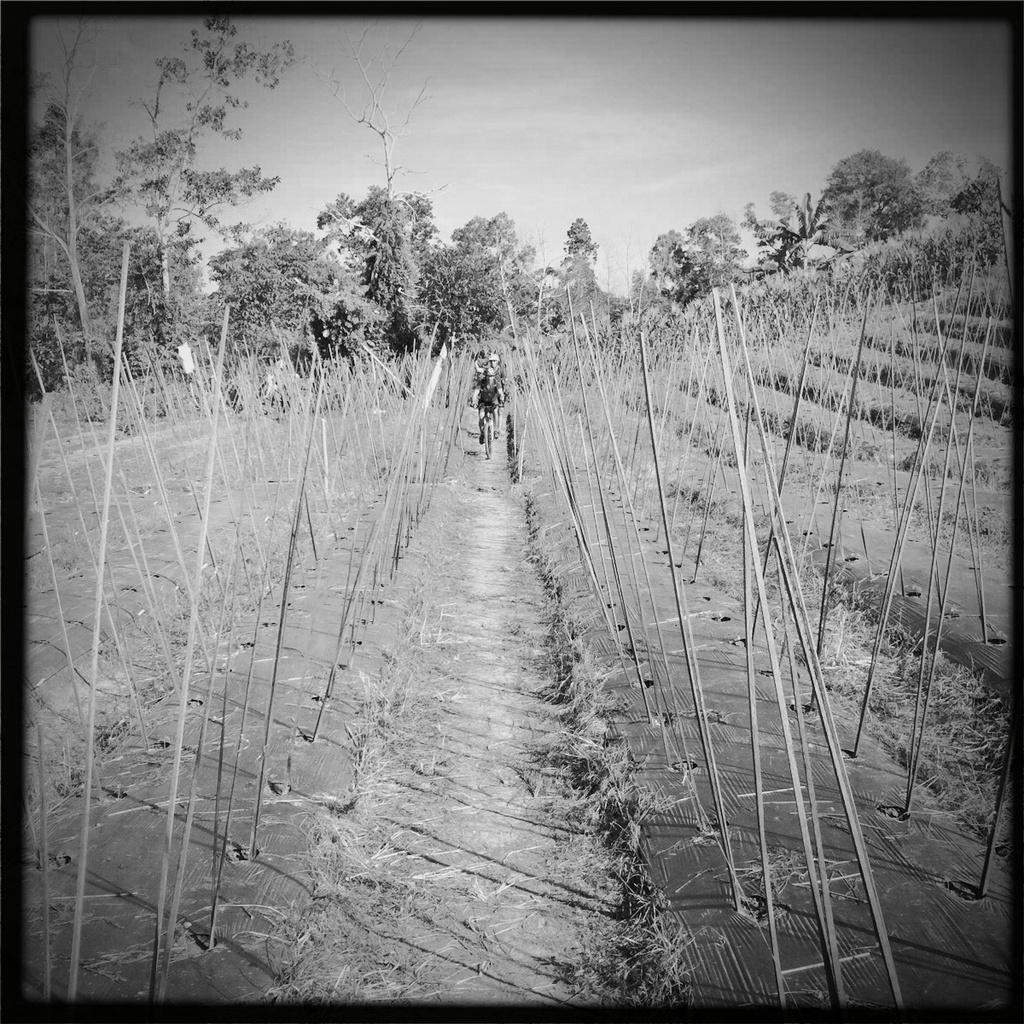What is the color scheme of the image? The image is black and white. What can be seen in the image besides the color scheme? There are people and sticks visible in the image. What is the background of the image? The background of the image includes trees and the sky. What activity is one of the people engaged in? A person is riding a bicycle in the image. What type of polish is being applied to the bicycle in the image? There is no polish being applied to the bicycle in the image; it is a black and white image, and no polish is visible. Are there any stockings visible on the people in the image? There is no information about stockings or clothing on the people in the image, as the focus is on the color scheme, subjects, and objects. 